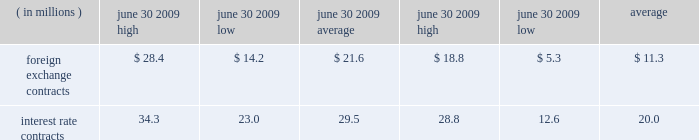In asset positions , which totaled $ 41.2 million at june 30 , 2009 .
To manage this risk , we have established strict counterparty credit guidelines that are continually monitored and reported to management .
Accordingly , management believes risk of loss under these hedging contracts is remote .
Certain of our derivative fi nancial instruments contain credit-risk-related contingent features .
As of june 30 , 2009 , we were in compliance with such features and there were no derivative financial instruments with credit-risk-related contingent features that were in a net liability position .
The est{e lauder companies inc .
111 market risk we use a value-at-risk model to assess the market risk of our derivative fi nancial instruments .
Value-at-risk rep resents the potential losses for an instrument or portfolio from adverse changes in market factors for a specifi ed time period and confi dence level .
We estimate value- at-risk across all of our derivative fi nancial instruments using a model with historical volatilities and correlations calculated over the past 250-day period .
The high , low and average measured value-at-risk for the twelve months ended june 30 , 2009 and 2008 related to our foreign exchange and interest rate contracts are as follows: .
The change in the value-at-risk measures from the prior year related to our foreign exchange contracts refl ected an increase in foreign exchange volatilities and a different portfolio mix .
The change in the value-at-risk measures from the prior year related to our interest rate contracts refl ected higher interest rate volatilities .
The model esti- mates were made assuming normal market conditions and a 95 percent confi dence level .
We used a statistical simulation model that valued our derivative fi nancial instruments against one thousand randomly generated market price paths .
Our calculated value-at-risk exposure represents an esti mate of reasonably possible net losses that would be recognized on our portfolio of derivative fi nancial instru- ments assuming hypothetical movements in future market rates and is not necessarily indicative of actual results , which may or may not occur .
It does not represent the maximum possible loss or any expected loss that may occur , since actual future gains and losses will differ from those estimated , based upon actual fl uctuations in market rates , operating exposures , and the timing thereof , and changes in our portfolio of derivative fi nancial instruments during the year .
We believe , however , that any such loss incurred would be offset by the effects of market rate movements on the respective underlying transactions for which the deriva- tive fi nancial instrument was intended .
Off-balance sheet arrangements we do not maintain any off-balance sheet arrangements , transactions , obligations or other relationships with unconsolidated entities that would be expected to have a material current or future effect upon our fi nancial condi- tion or results of operations .
Recently adopted accounting standards in may 2009 , the financial accounting standards board ( 201cfasb 201d ) issued statement of financial accounting standards ( 201csfas 201d ) no .
165 , 201csubsequent events 201d ( 201csfas no .
165 201d ) .
Sfas no .
165 requires the disclosure of the date through which an entity has evaluated subsequent events for potential recognition or disclosure in the fi nan- cial statements and whether that date represents the date the fi nancial statements were issued or were available to be issued .
This standard also provides clarifi cation about circumstances under which an entity should recognize events or transactions occurring after the balance sheet date in its fi nancial statements and the disclosures that an entity should make about events or transactions that occurred after the balance sheet date .
This standard is effective for interim and annual periods beginning with our fi scal year ended june 30 , 2009 .
The adoption of this standard did not have a material impact on our consoli- dated fi nancial statements .
In march 2008 , the fasb issued sfas no .
161 , 201cdisclosures about derivative instruments and hedging activities 2014 an amendment of fasb statement no .
133 201d ( 201csfas no .
161 201d ) .
Sfas no .
161 requires companies to provide qualitative disclosures about their objectives and strategies for using derivative instruments , quantitative disclosures of the fair values of , and gains and losses on , these derivative instruments in a tabular format , as well as more information about liquidity by requiring disclosure of a derivative contract 2019s credit-risk-related contingent .
Considering the foreign exchange contracts , what is the difference between its average during 2008 and 2009? 
Rationale: it is the variation between these values.\\n
Computations: (21.6 - 11.3)
Answer: 10.3. 